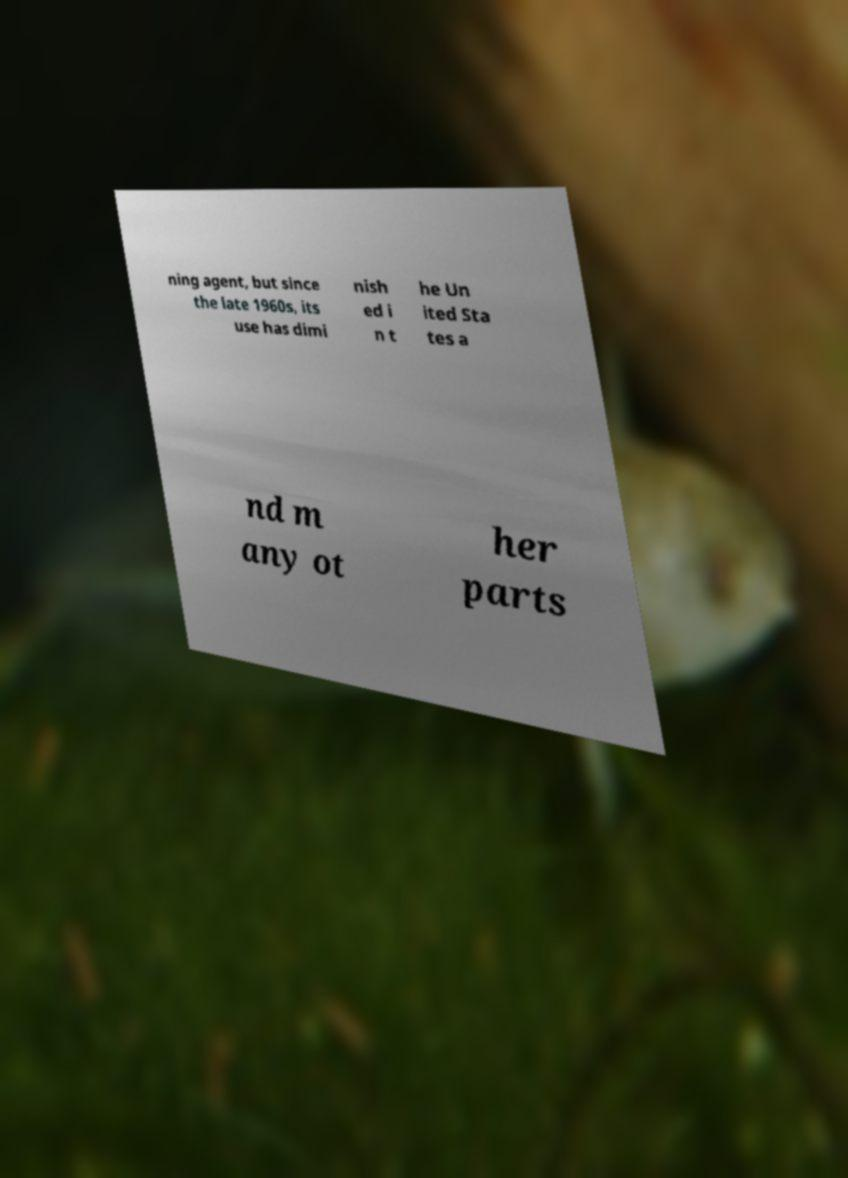Please read and relay the text visible in this image. What does it say? ning agent, but since the late 1960s, its use has dimi nish ed i n t he Un ited Sta tes a nd m any ot her parts 